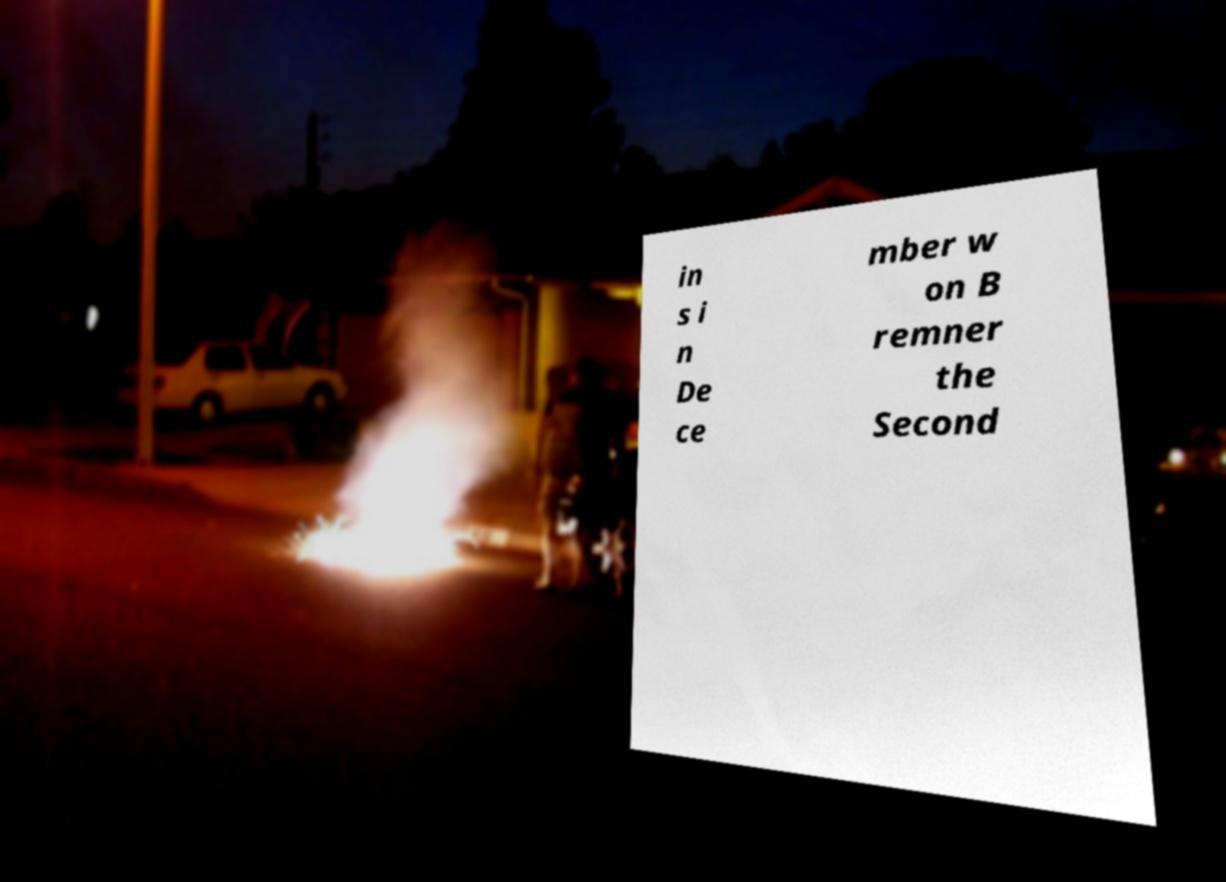Can you accurately transcribe the text from the provided image for me? in s i n De ce mber w on B remner the Second 